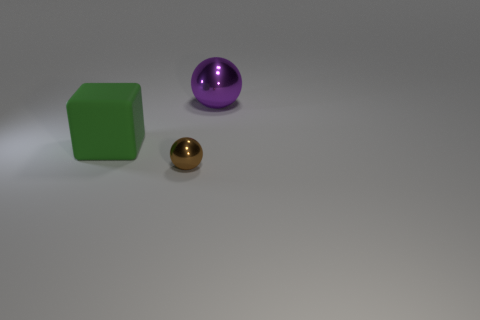Subtract all purple balls. How many balls are left? 1 Add 1 small green metal objects. How many objects exist? 4 Subtract all blocks. How many objects are left? 2 Subtract 1 balls. How many balls are left? 1 Subtract all big blue balls. Subtract all brown metallic balls. How many objects are left? 2 Add 1 brown metallic spheres. How many brown metallic spheres are left? 2 Add 1 large matte objects. How many large matte objects exist? 2 Subtract 0 yellow spheres. How many objects are left? 3 Subtract all red balls. Subtract all cyan cylinders. How many balls are left? 2 